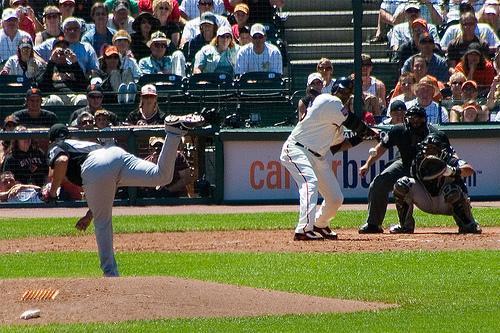How many people are visible?
Give a very brief answer. 5. 